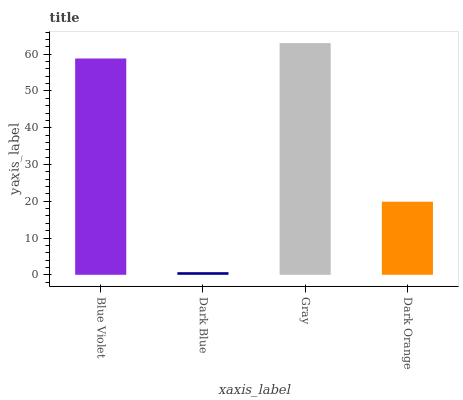Is Dark Blue the minimum?
Answer yes or no. Yes. Is Gray the maximum?
Answer yes or no. Yes. Is Gray the minimum?
Answer yes or no. No. Is Dark Blue the maximum?
Answer yes or no. No. Is Gray greater than Dark Blue?
Answer yes or no. Yes. Is Dark Blue less than Gray?
Answer yes or no. Yes. Is Dark Blue greater than Gray?
Answer yes or no. No. Is Gray less than Dark Blue?
Answer yes or no. No. Is Blue Violet the high median?
Answer yes or no. Yes. Is Dark Orange the low median?
Answer yes or no. Yes. Is Gray the high median?
Answer yes or no. No. Is Blue Violet the low median?
Answer yes or no. No. 